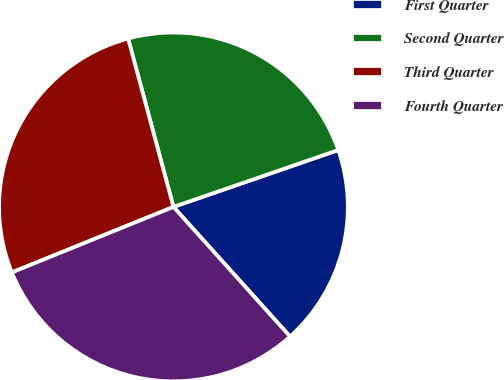<chart> <loc_0><loc_0><loc_500><loc_500><pie_chart><fcel>First Quarter<fcel>Second Quarter<fcel>Third Quarter<fcel>Fourth Quarter<nl><fcel>18.63%<fcel>23.9%<fcel>26.94%<fcel>30.53%<nl></chart> 